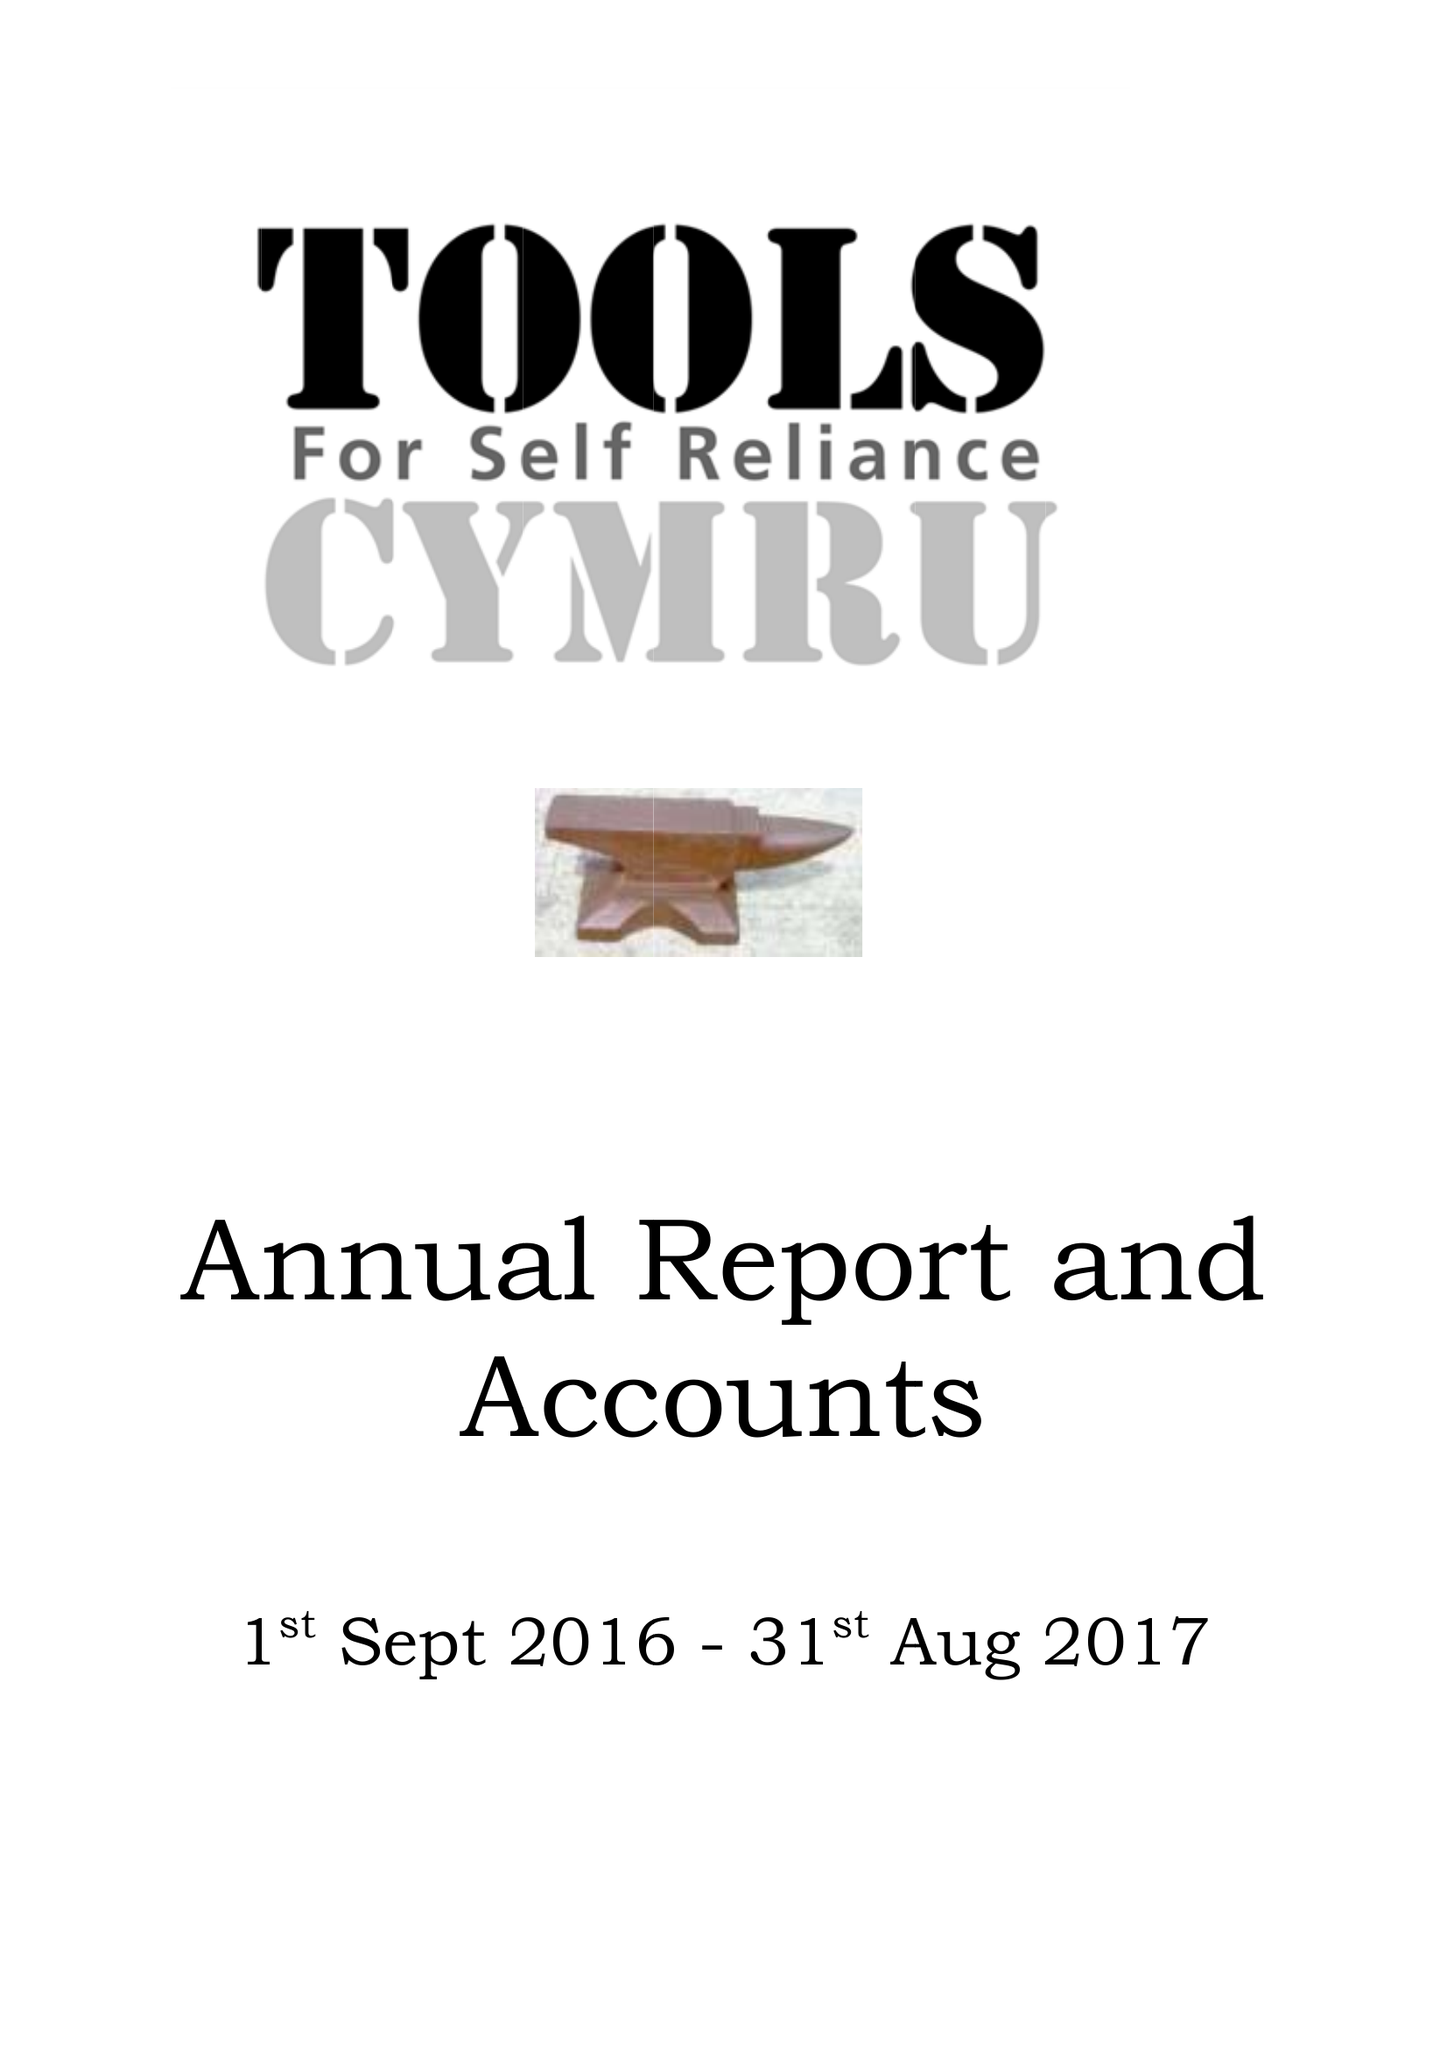What is the value for the charity_name?
Answer the question using a single word or phrase. Tools For Self Reliance Cymru Ltd. 